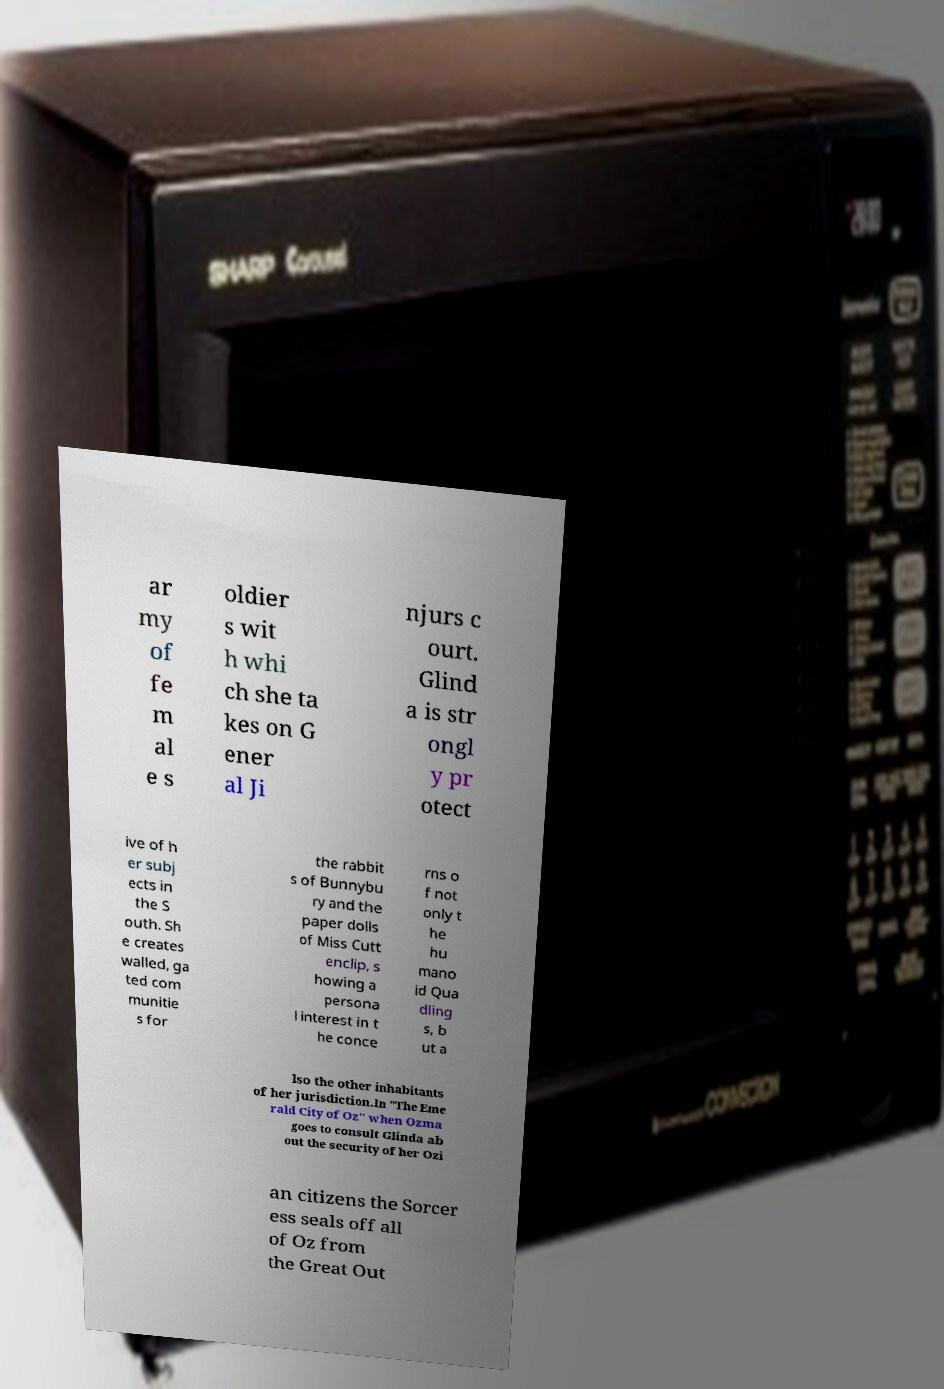I need the written content from this picture converted into text. Can you do that? ar my of fe m al e s oldier s wit h whi ch she ta kes on G ener al Ji njurs c ourt. Glind a is str ongl y pr otect ive of h er subj ects in the S outh. Sh e creates walled, ga ted com munitie s for the rabbit s of Bunnybu ry and the paper dolls of Miss Cutt enclip, s howing a persona l interest in t he conce rns o f not only t he hu mano id Qua dling s, b ut a lso the other inhabitants of her jurisdiction.In "The Eme rald City of Oz" when Ozma goes to consult Glinda ab out the security of her Ozi an citizens the Sorcer ess seals off all of Oz from the Great Out 